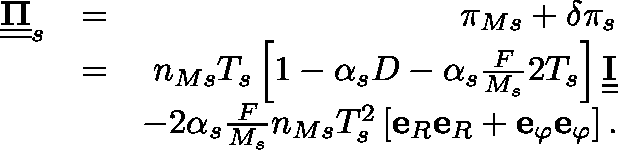Convert formula to latex. <formula><loc_0><loc_0><loc_500><loc_500>\begin{array} { r l r } { \underline { { \underline { \Pi } } } _ { s } } & { = } & { \pi _ { M s } + \delta \pi _ { s } } \\ & { = } & { n _ { M s } T _ { s } \left [ 1 - \alpha _ { s } D - \alpha _ { s } \frac { F } { M _ { s } } 2 T _ { s } \right ] \underline { { \underline { I } } } } \\ & { - 2 \alpha _ { s } \frac { F } { M _ { s } } n _ { M s } T _ { s } ^ { 2 } \left [ e _ { R } e _ { R } + e _ { \varphi } e _ { \varphi } \right ] . } \end{array}</formula> 